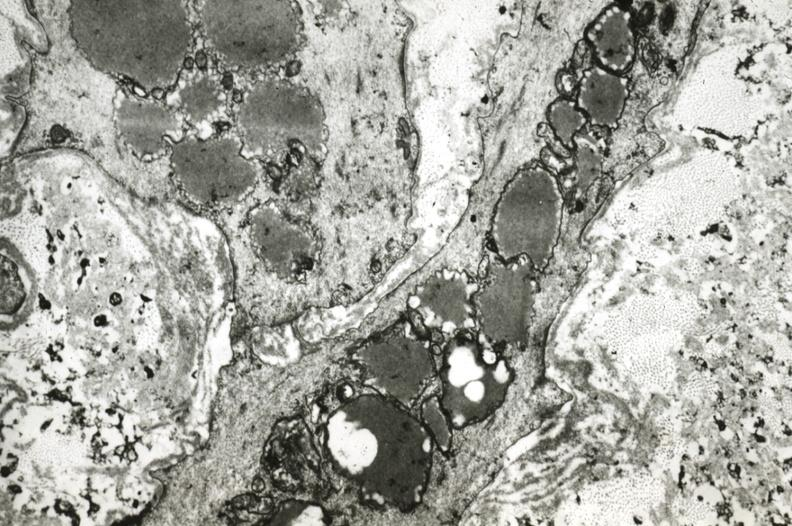s cardiovascular present?
Answer the question using a single word or phrase. Yes 